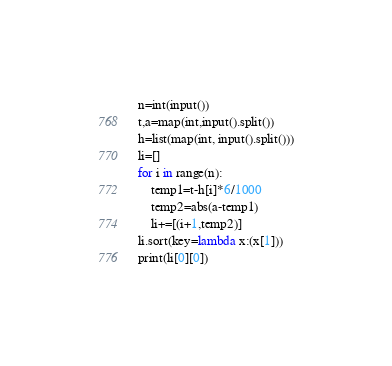<code> <loc_0><loc_0><loc_500><loc_500><_Python_>n=int(input())
t,a=map(int,input().split())
h=list(map(int, input().split()))
li=[]
for i in range(n):
    temp1=t-h[i]*6/1000
    temp2=abs(a-temp1)
    li+=[(i+1,temp2)]
li.sort(key=lambda x:(x[1]))
print(li[0][0])</code> 